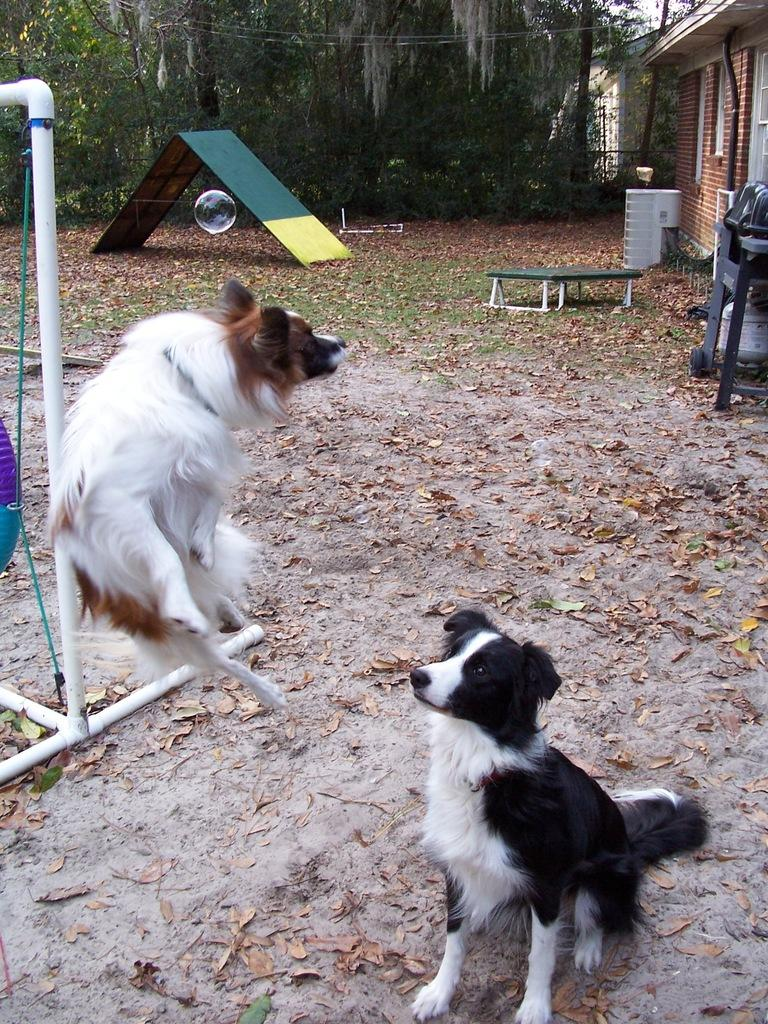What animals are in the center of the image? There are two dogs in the center of the image. What structures or objects can be seen in the background of the image? There is a tent, a bench, a building, trees, and a pole in the background of the image. What type of watch is the dog wearing in the image? There are no watches present in the image, and the dogs are not wearing any accessories. 